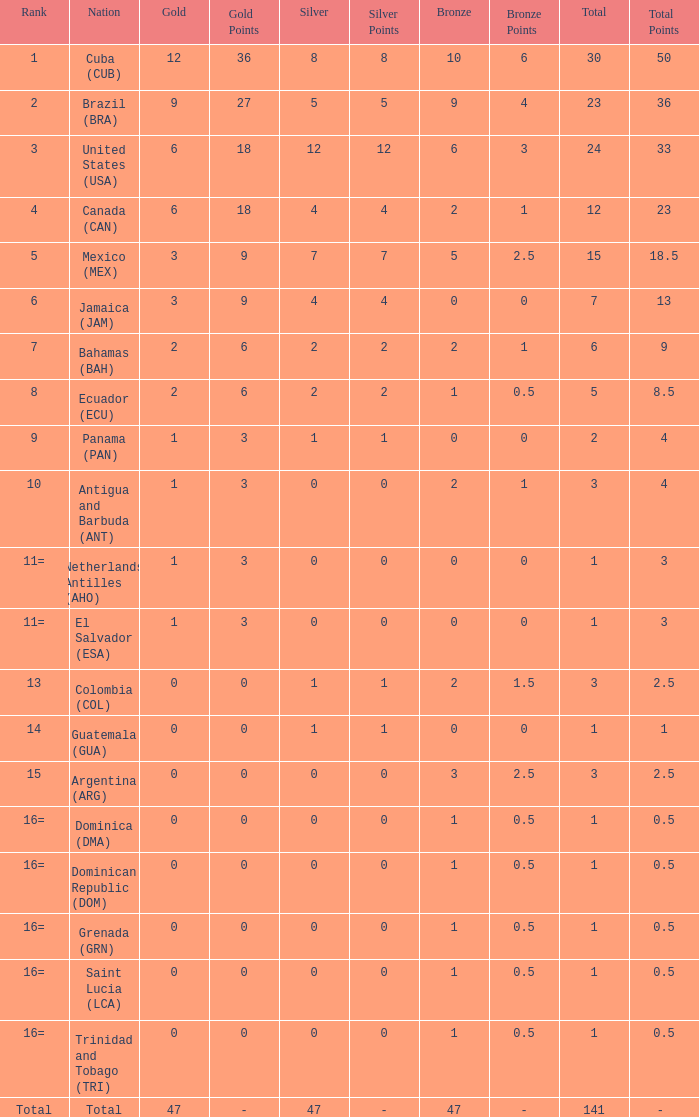What is the total gold with a total less than 1? None. 